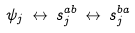<formula> <loc_0><loc_0><loc_500><loc_500>\psi _ { j } \, \leftrightarrow \, { s } ^ { a b } _ { j } \, \leftrightarrow \, { s } ^ { b a } _ { j }</formula> 